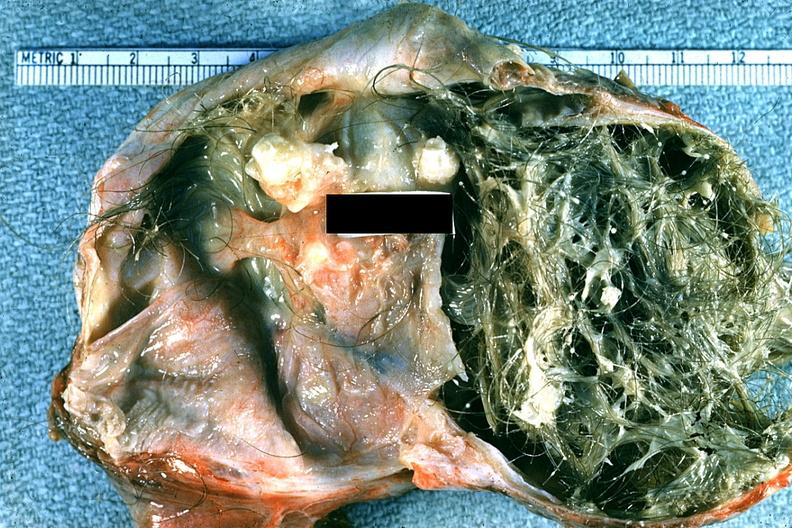s ovary present?
Answer the question using a single word or phrase. Yes 